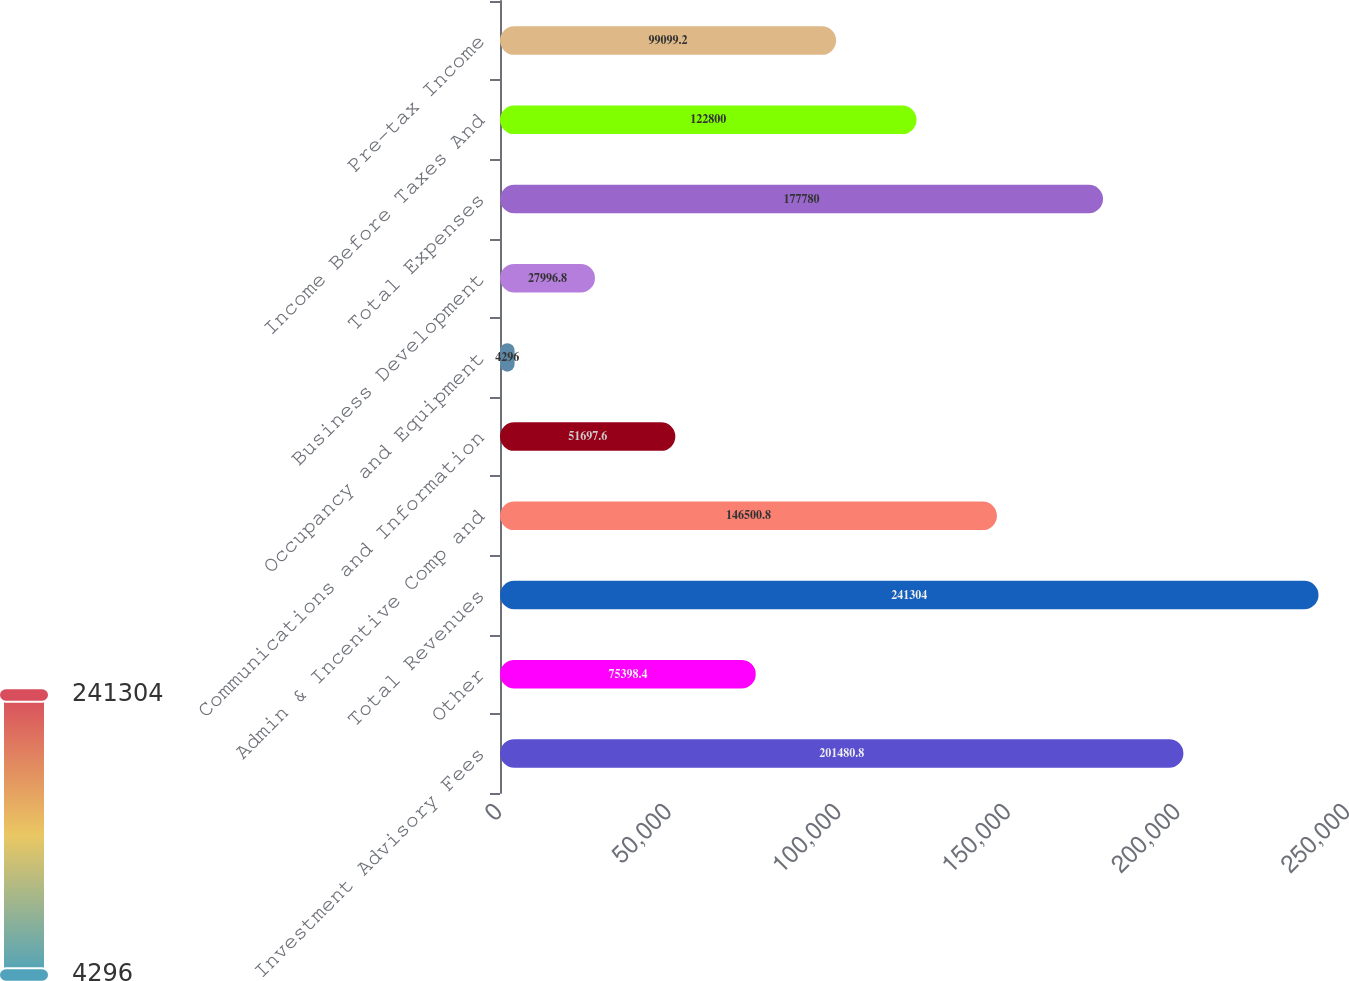Convert chart. <chart><loc_0><loc_0><loc_500><loc_500><bar_chart><fcel>Investment Advisory Fees<fcel>Other<fcel>Total Revenues<fcel>Admin & Incentive Comp and<fcel>Communications and Information<fcel>Occupancy and Equipment<fcel>Business Development<fcel>Total Expenses<fcel>Income Before Taxes And<fcel>Pre-tax Income<nl><fcel>201481<fcel>75398.4<fcel>241304<fcel>146501<fcel>51697.6<fcel>4296<fcel>27996.8<fcel>177780<fcel>122800<fcel>99099.2<nl></chart> 